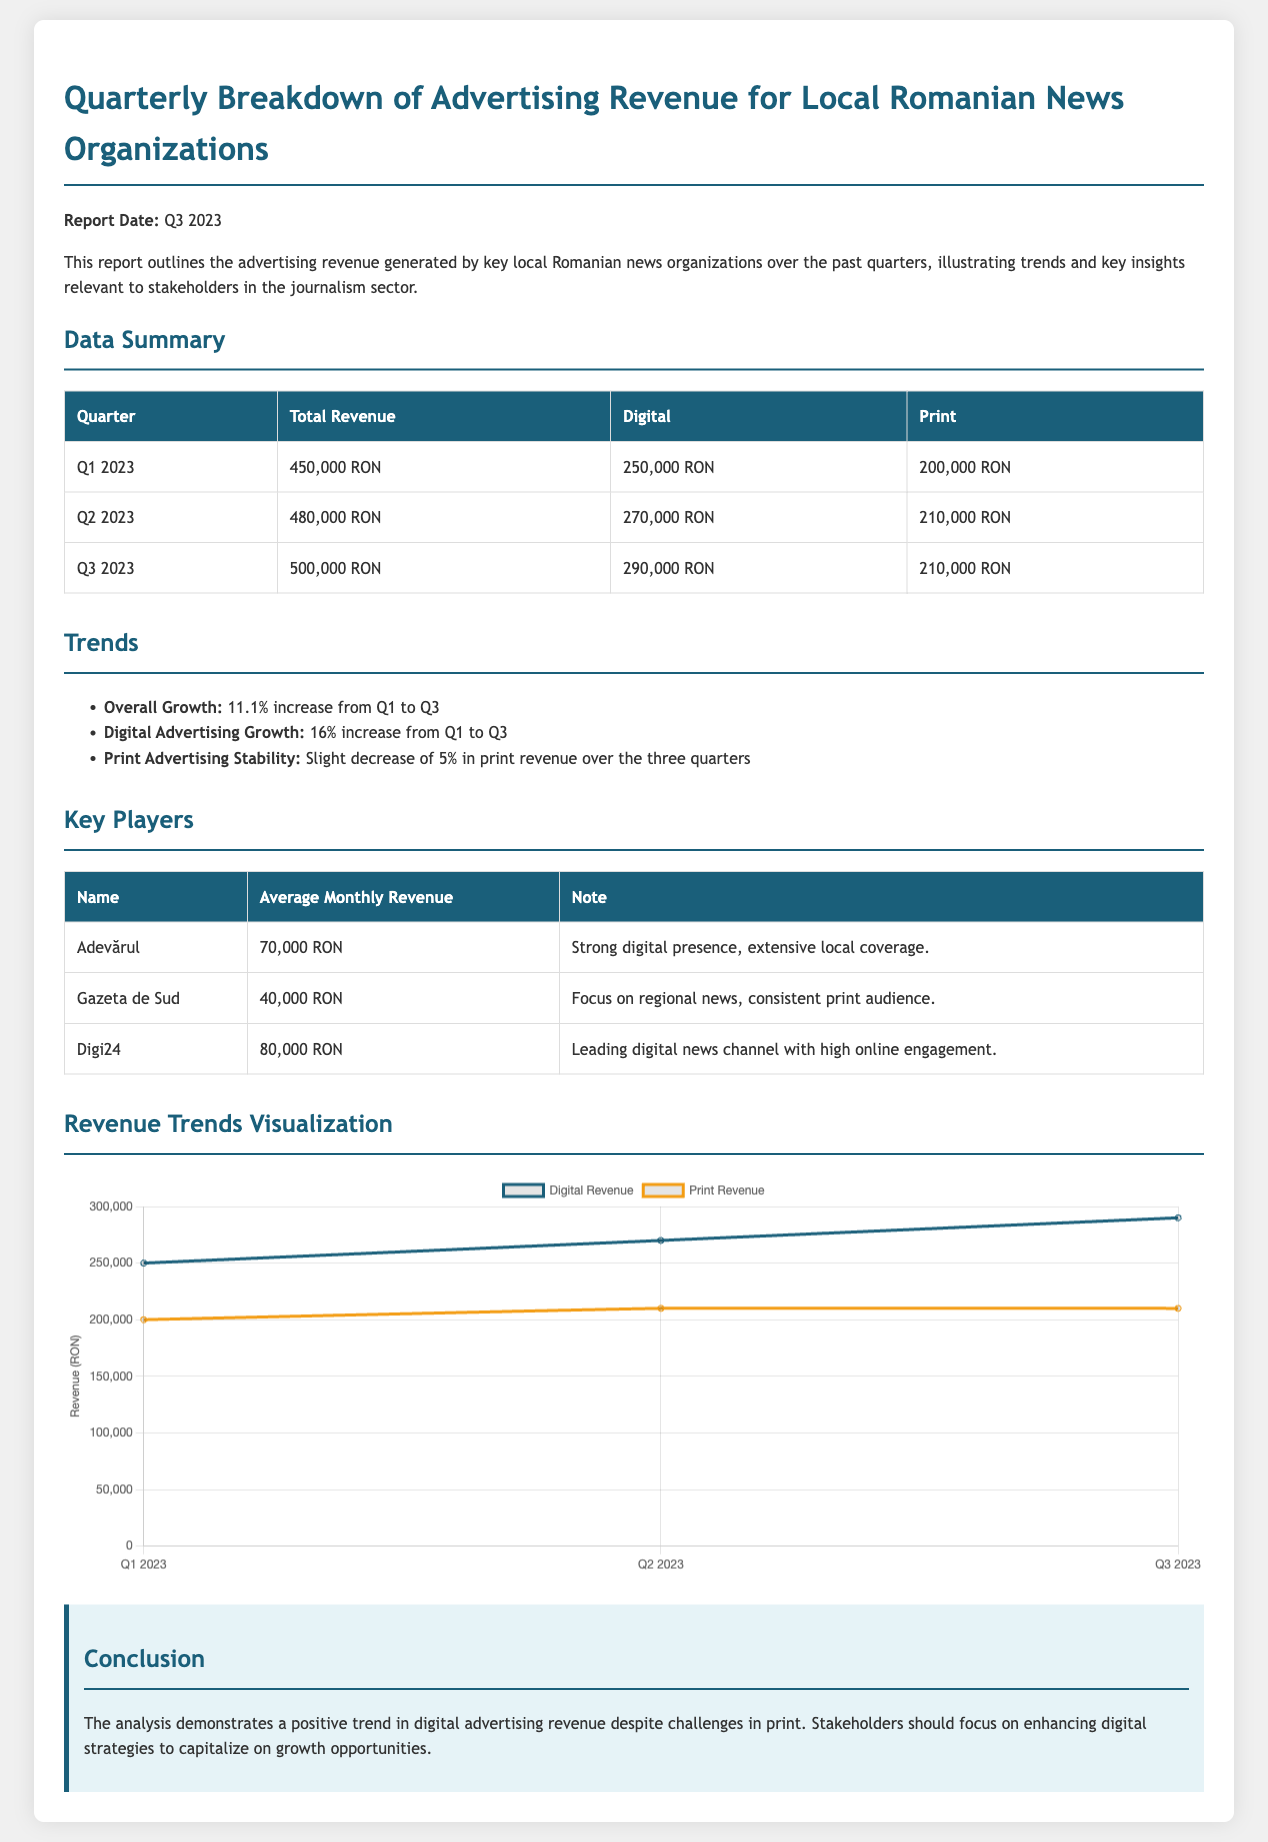What is the total revenue for Q1 2023? The total revenue for Q1 2023 is stated in the data summary table.
Answer: 450,000 RON What was the digital revenue in Q2 2023? The digital revenue figure for Q2 2023 is provided in the data summary table.
Answer: 270,000 RON Which organization has the highest average monthly revenue? The key players table lists the average monthly revenue for each organization; Digi24 has the highest.
Answer: Digi24 What is the percentage increase in total revenue from Q1 to Q3 2023? The report highlights overall growth, which includes specific percentage increases from Q1 to Q3.
Answer: 11.1% What trend is observed in print advertising revenue from Q1 to Q3 2023? The trends section discusses the changes in print revenue, noting any decreases or stability.
Answer: Slight decrease What is the average monthly revenue of Adevărul? Adevărul's average monthly revenue is detailed in the key players table.
Answer: 70,000 RON What are the two types of revenue compared in the trends visualization? The chart specifies the types of revenue visualized, which are identified in the script section.
Answer: Digital and Print Which quarter had the highest total revenue? The total revenue figures for each quarter are summarized in the data summary section.
Answer: Q3 2023 